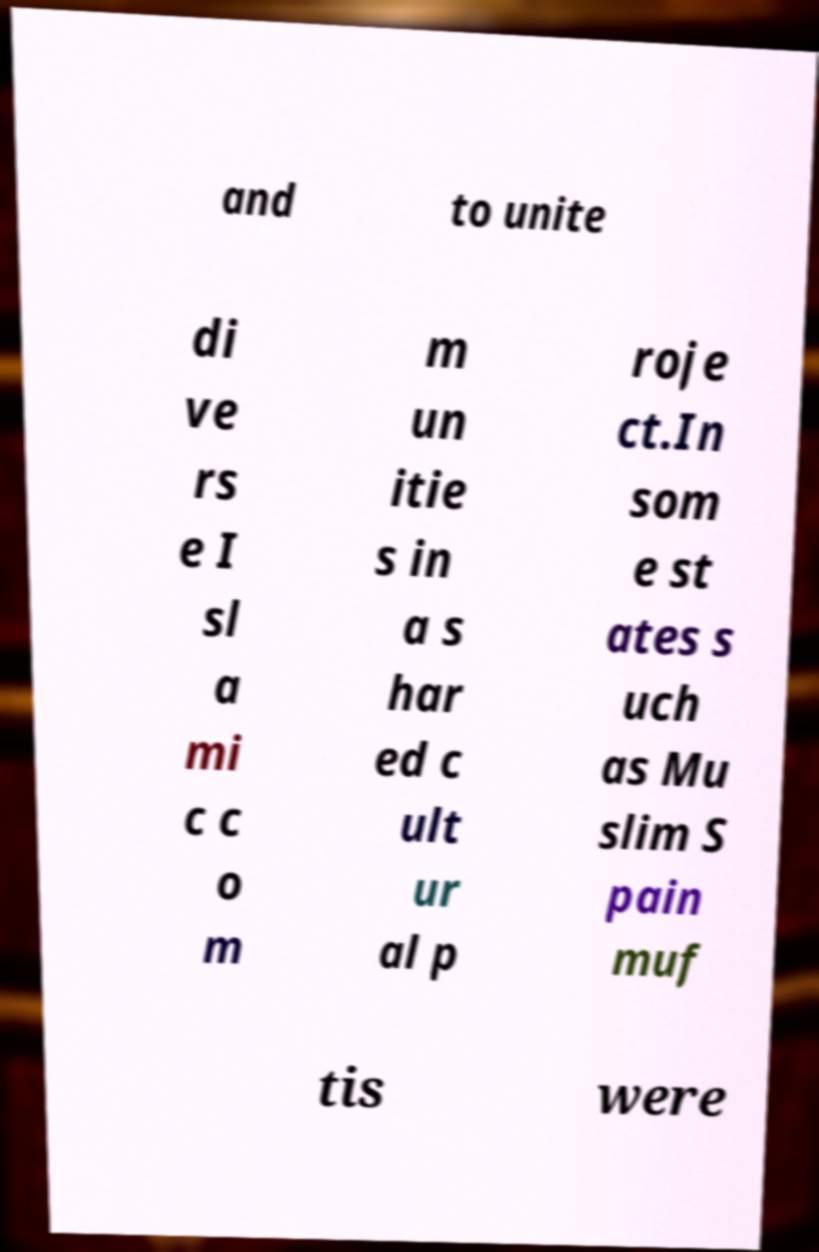What messages or text are displayed in this image? I need them in a readable, typed format. and to unite di ve rs e I sl a mi c c o m m un itie s in a s har ed c ult ur al p roje ct.In som e st ates s uch as Mu slim S pain muf tis were 